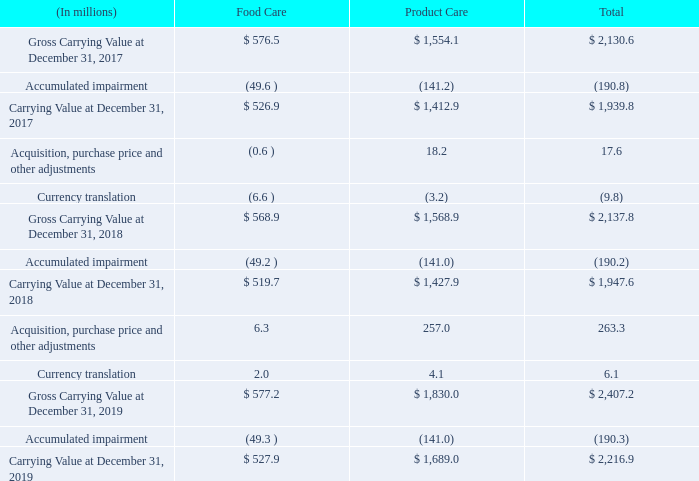Allocation of Goodwill to Reporting Segment
The following table shows our goodwill balances by reportable segment:
As noted above, it was determined under a quantitative assessment that there was no impairment of goodwill. However, if we become aware of indicators of impairment in future periods, we may be required to perform an interim assessment for some or all of our reporting units before the next annual assessment. Examples of such indicators may include a decrease in expected net earnings, adverse equity market conditions, a decline in current market multiples, a decline in our common stock price, a significant adverse change in legal factors or business climates, an adverse action or assessment by a regulator, unanticipated competition, strategic decisions made in response to economic or competitive conditions, or a more likely than not expectation that a reporting unit or a significant portion of a reporting unit will be sold or disposed of. In the event of significant adverse changes of the nature described above, we may have to recognize a non-cash impairment of goodwill, which could have a material adverse effect on our consolidated financial condition and results of operations.
What does the table show? Shows our goodwill balances by reportable segment. What are examples of indicator of impairment of goodwill? Examples of such indicators may include a decrease in expected net earnings, adverse equity market conditions, a decline in current market multiples, a decline in our common stock price, a significant adverse change in legal factors or business climates, an adverse action or assessment by a regulator, unanticipated competition, strategic decisions made in response to economic or competitive conditions, or a more likely than not expectation that a reporting unit or a significant portion of a reporting unit will be sold or disposed of. What is the impact of a significant adverse impairment of goodwill? We may have to recognize a non-cash impairment of goodwill, which could have a material adverse effect on our consolidated financial condition and results of operations. What is the average annual growth rate of Carrying value for Food Care for years 2017-2019?
Answer scale should be: percent. [(519.7-526.9)/526.9+(527.9-519.7)/519.7]/2
Answer: 0.11. What is Total Accumulated impairment expressed as a percentage of Gross Carrying Value for 2019?
Answer scale should be: percent. 190.3/2,407.2
Answer: 7.91. What is the Average total Carrying Value for years 2017-2019?
Answer scale should be: million. (2,216.9+1,947.6+1,939.8)/3
Answer: 2034.77. 